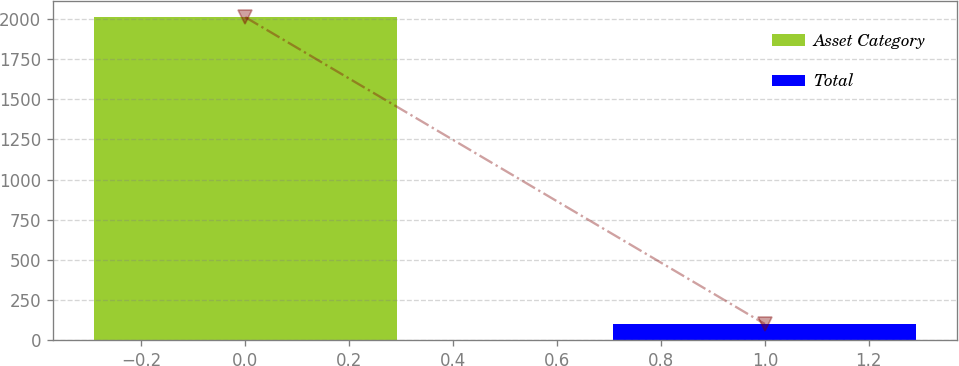Convert chart. <chart><loc_0><loc_0><loc_500><loc_500><bar_chart><fcel>Asset Category<fcel>Total<nl><fcel>2012<fcel>100<nl></chart> 